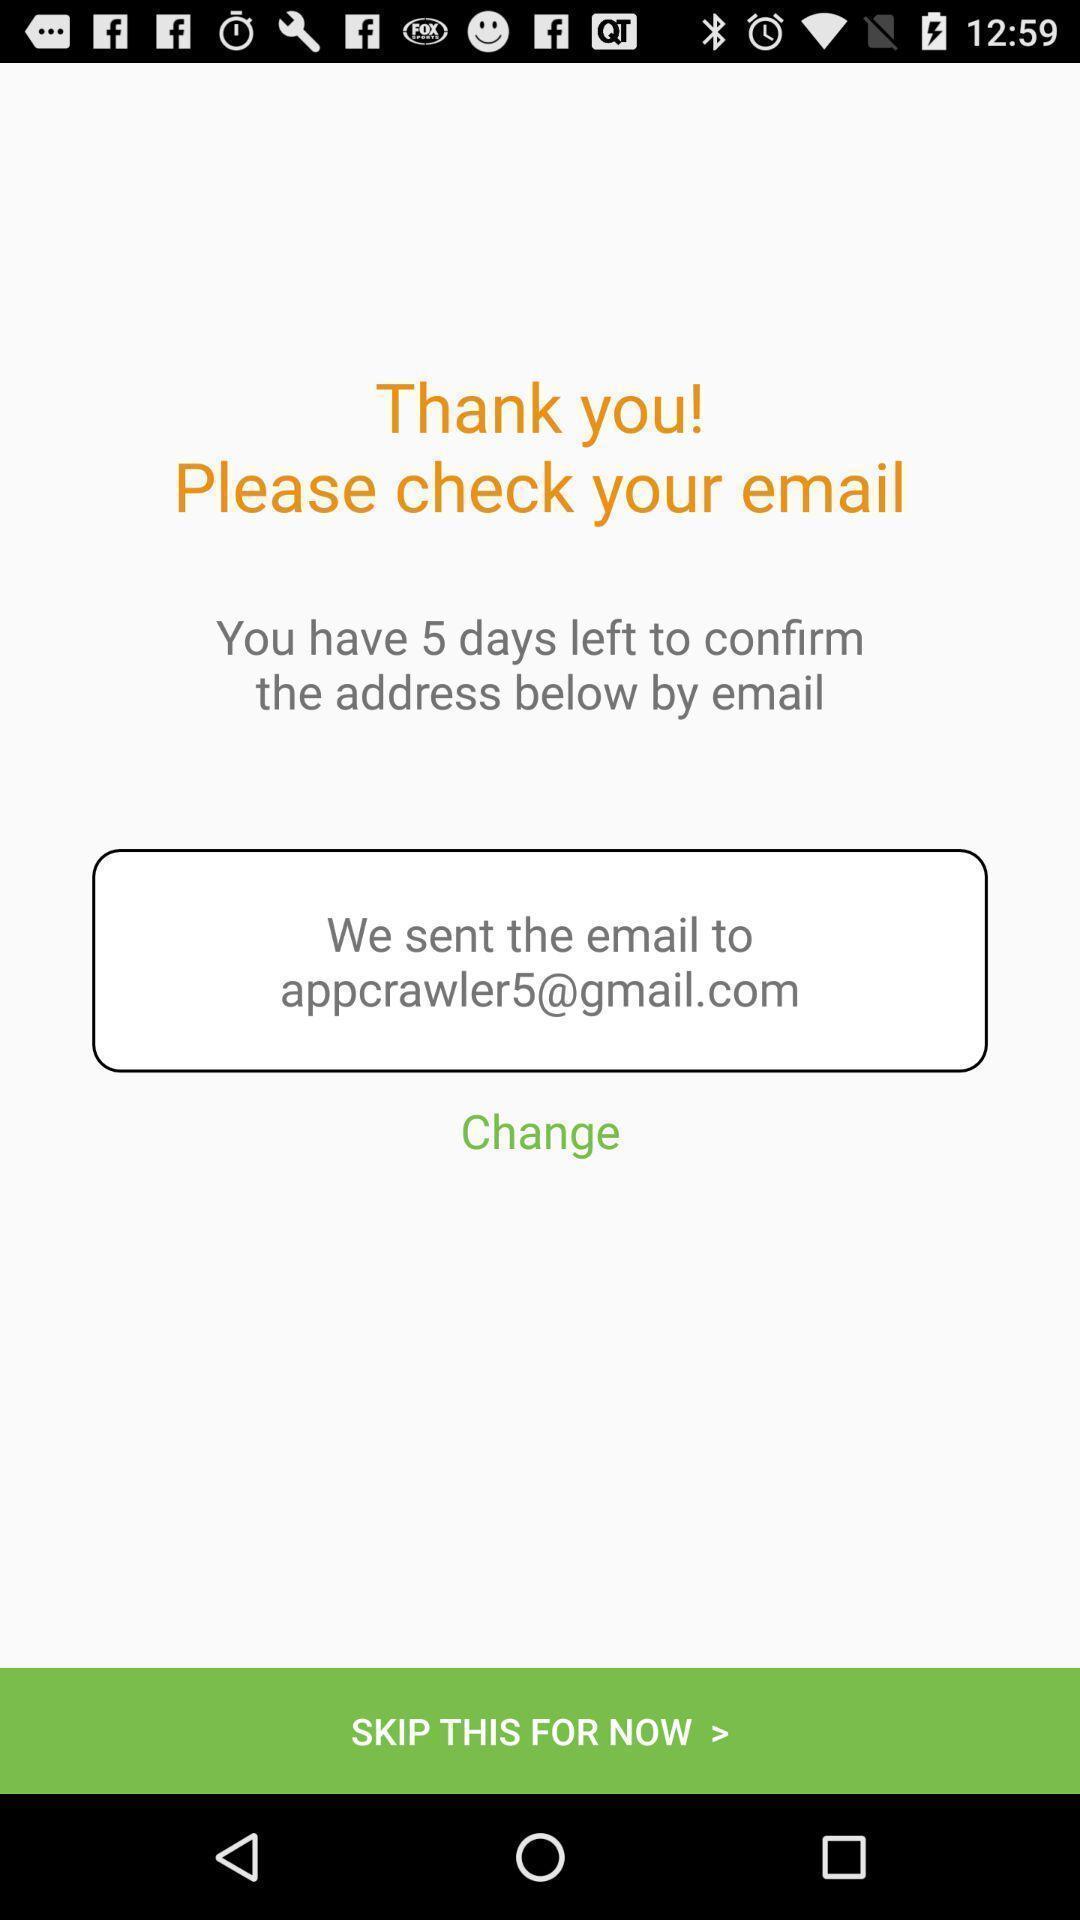Give me a narrative description of this picture. Thank you page for the email application. 